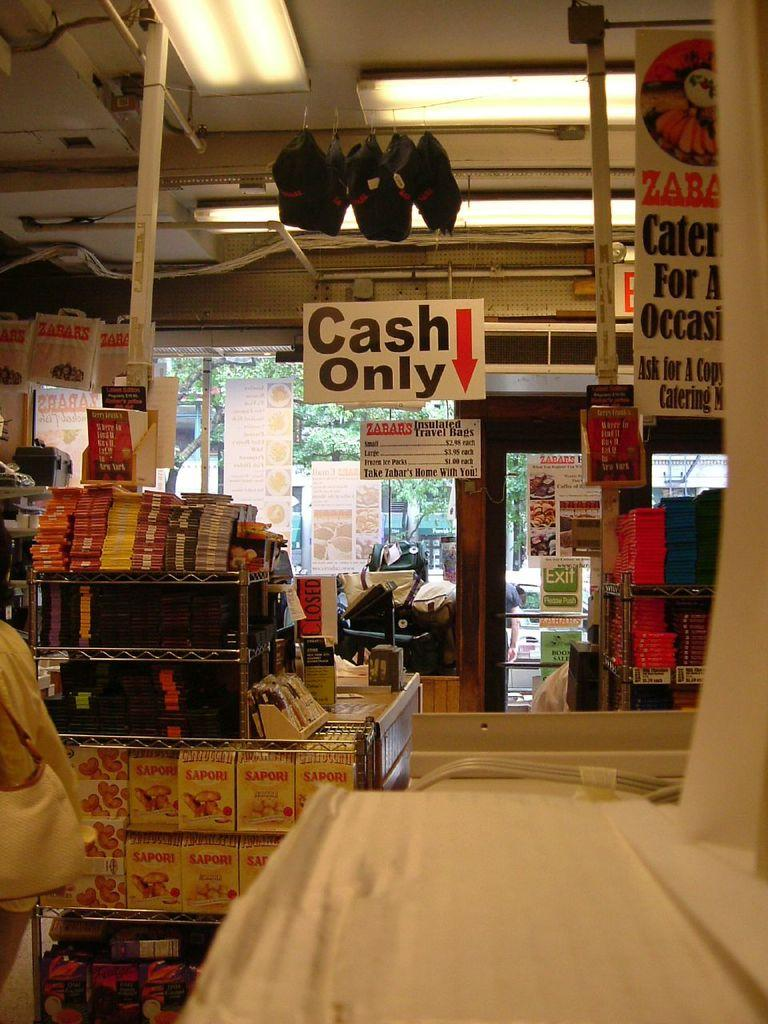Provide a one-sentence caption for the provided image. Store very packed with goods and sign "Cash Only" up above. 